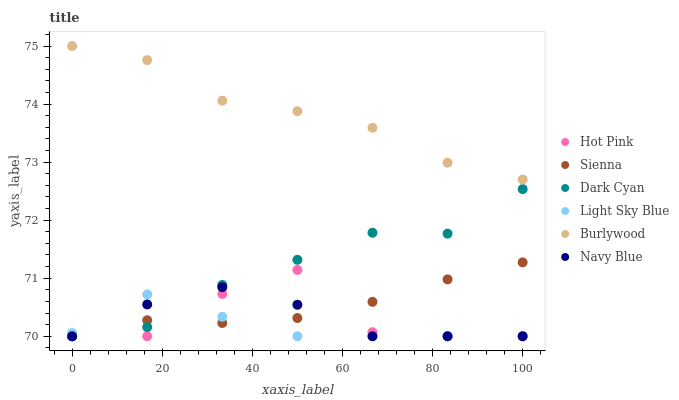Does Light Sky Blue have the minimum area under the curve?
Answer yes or no. Yes. Does Burlywood have the maximum area under the curve?
Answer yes or no. Yes. Does Navy Blue have the minimum area under the curve?
Answer yes or no. No. Does Navy Blue have the maximum area under the curve?
Answer yes or no. No. Is Sienna the smoothest?
Answer yes or no. Yes. Is Hot Pink the roughest?
Answer yes or no. Yes. Is Navy Blue the smoothest?
Answer yes or no. No. Is Navy Blue the roughest?
Answer yes or no. No. Does Navy Blue have the lowest value?
Answer yes or no. Yes. Does Burlywood have the highest value?
Answer yes or no. Yes. Does Navy Blue have the highest value?
Answer yes or no. No. Is Hot Pink less than Burlywood?
Answer yes or no. Yes. Is Burlywood greater than Sienna?
Answer yes or no. Yes. Does Light Sky Blue intersect Hot Pink?
Answer yes or no. Yes. Is Light Sky Blue less than Hot Pink?
Answer yes or no. No. Is Light Sky Blue greater than Hot Pink?
Answer yes or no. No. Does Hot Pink intersect Burlywood?
Answer yes or no. No. 